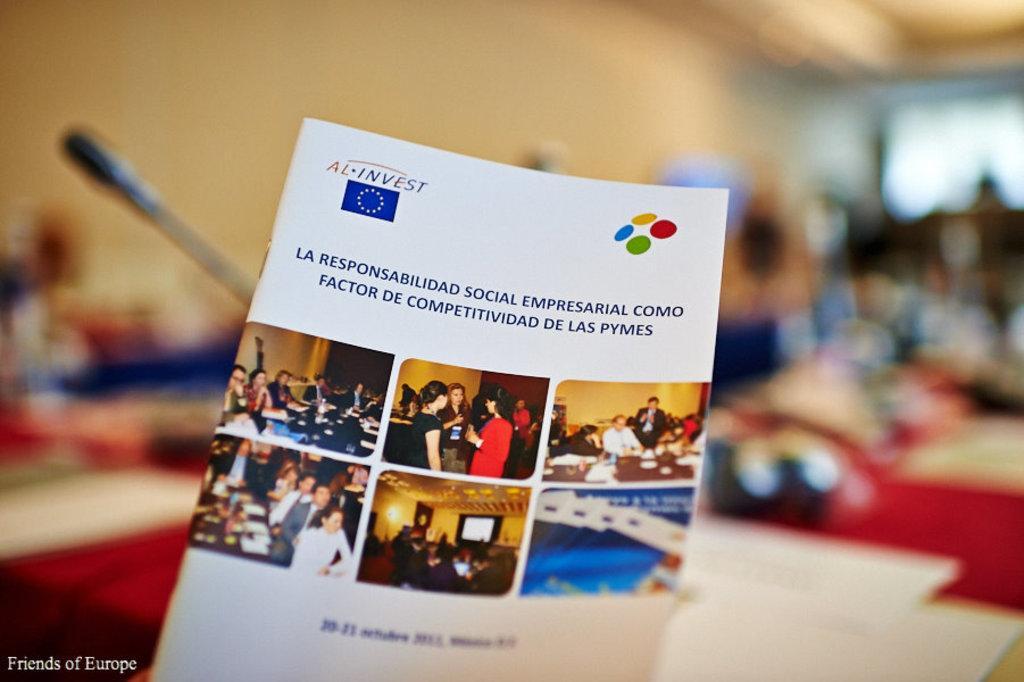What type of book is visible in the image? There is a book with photos in the image. Is there any text or writing on the book? Yes, something is written on the book. Can you describe the background of the image? The background of the image is blurred. What can be seen in the left corner of the image? There is a watermark in the left corner of the image. What type of hat is the parent wearing in the image? There is no parent or hat present in the image; it only features a book with photos and a blurred background. 